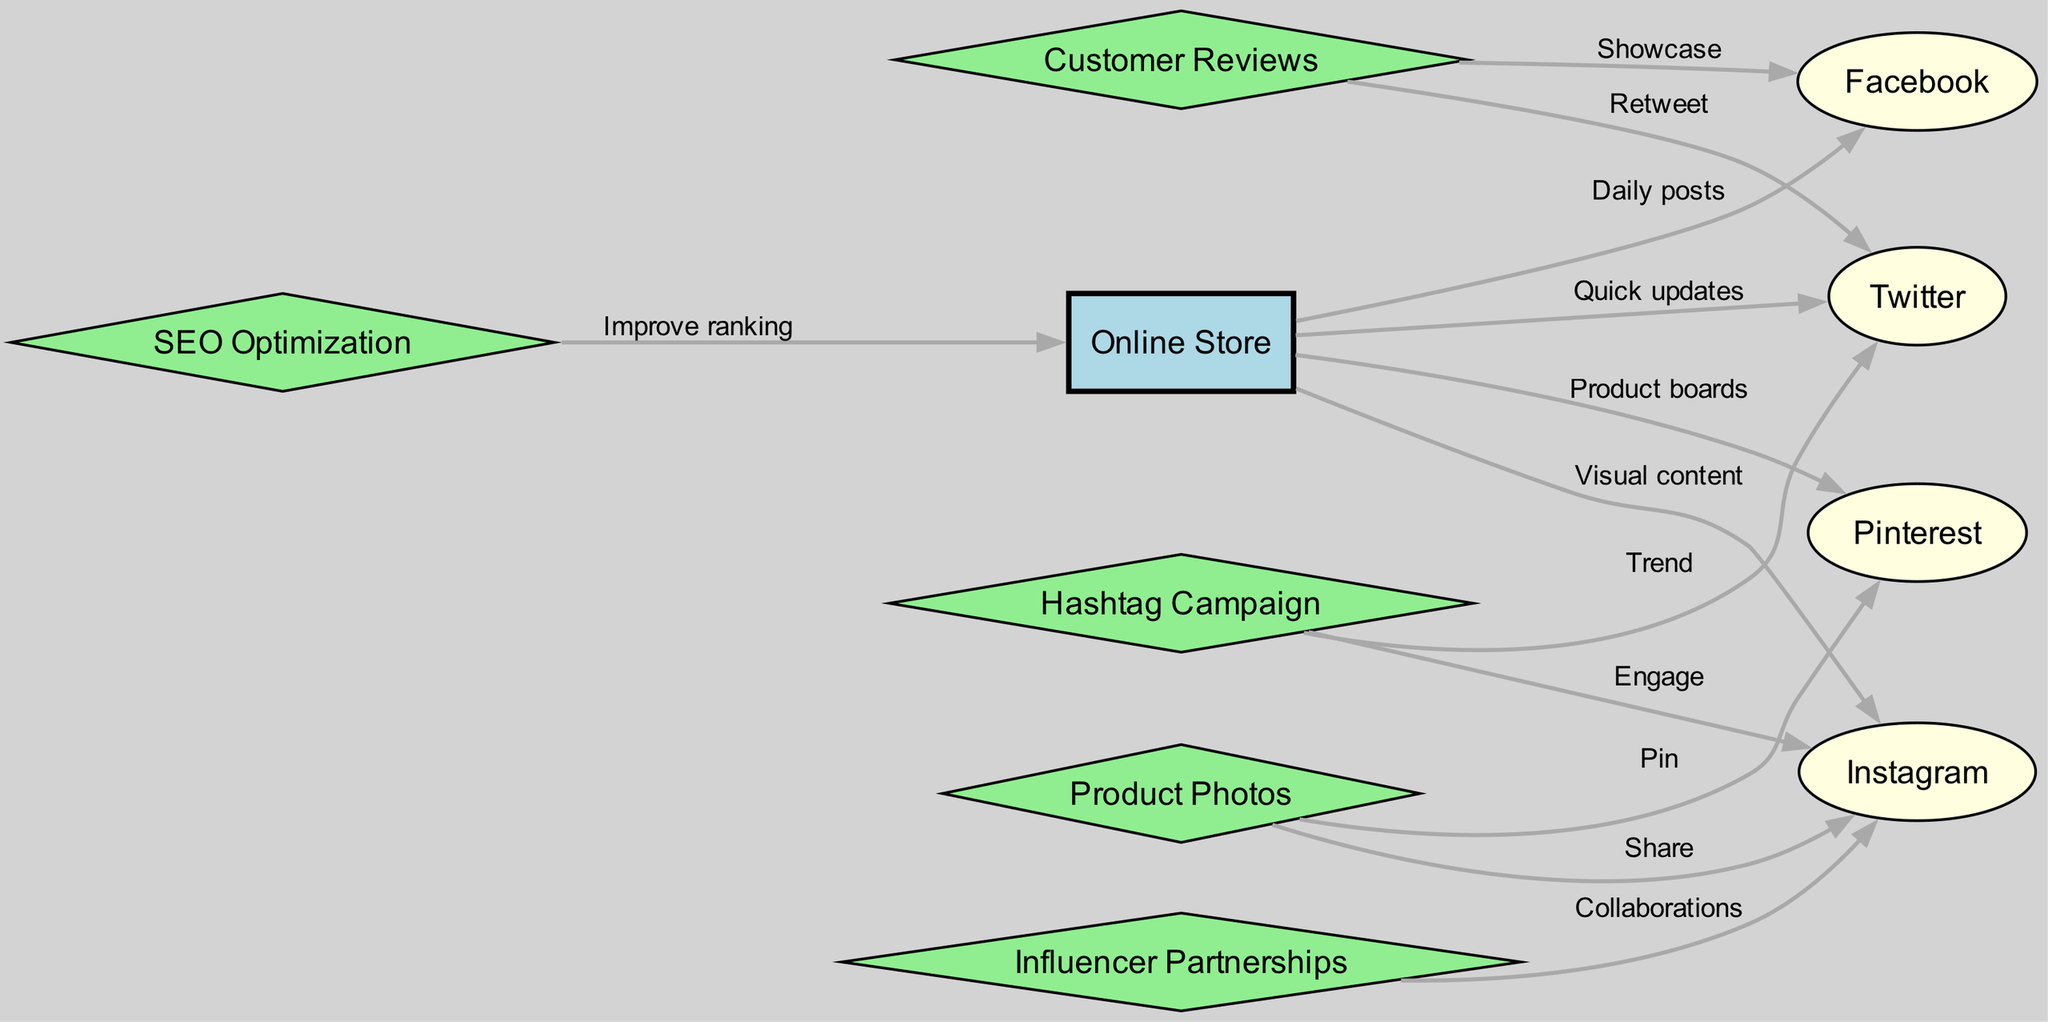What is the total number of nodes in the diagram? The diagram lists the following nodes: Online Store, Facebook, Instagram, Twitter, Pinterest, Product Photos, Customer Reviews, Influencer Partnerships, Hashtag Campaign, and SEO Optimization. Counting these gives a total of 10 nodes.
Answer: 10 How many edges originate from the Online Store? By examining the edges, we find that they originate from the Online Store to Facebook, Instagram, Twitter, Pinterest, and also to SEO Optimization. This totals 5 edges.
Answer: 5 Which social media platform is linked to the hashtag campaign? The diagram indicates that the hashtag campaign connects to both Twitter and Instagram. Since the question asks for the platforms, either can be considered a valid answer.
Answer: Twitter What type of content does the Online Store share on Instagram? The edge from the Online Store to Instagram is labeled "Visual content," indicating that the type of content shared on Instagram is visual in nature.
Answer: Visual content Which node has an outgoing edge to SEO Optimization? The only edge leading to the Online Store is linked to SEO Optimization, which illustrates that the SEO process is aimed at improving the ranking of the Online Store.
Answer: Online Store How many types of content link to Pinterest? The diagram shows one edge from Product Photos and another from the Online Store directing to Pinterest. Hence, there are two types of content connected to Pinterest.
Answer: 2 Which platform features customer reviews? The edges from Customer Reviews show that they are presented on Facebook, where they are showcased, and retweeted on Twitter, detailing the interaction with these reviews.
Answer: Facebook What is the relationship between Influencer Partnerships and Instagram? The edge from Influencer Partnerships to Instagram is labeled “Collaborations,” indicating that influencer partnerships are specifically aimed at collaboration on Instagram.
Answer: Collaborations How many social media platforms share content from Product Photos? Product Photos has outgoing edges leading to both Instagram (where it's "Shared") and Pinterest (where it's "Pinned"), totaling two platforms sharing content from Product Photos.
Answer: 2 